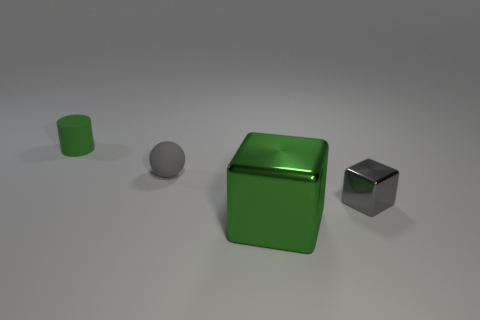Add 2 tiny green cylinders. How many objects exist? 6 Subtract all balls. How many objects are left? 3 Subtract all big blocks. Subtract all small red shiny blocks. How many objects are left? 3 Add 3 small gray shiny objects. How many small gray shiny objects are left? 4 Add 2 big cyan matte blocks. How many big cyan matte blocks exist? 2 Subtract 0 brown blocks. How many objects are left? 4 